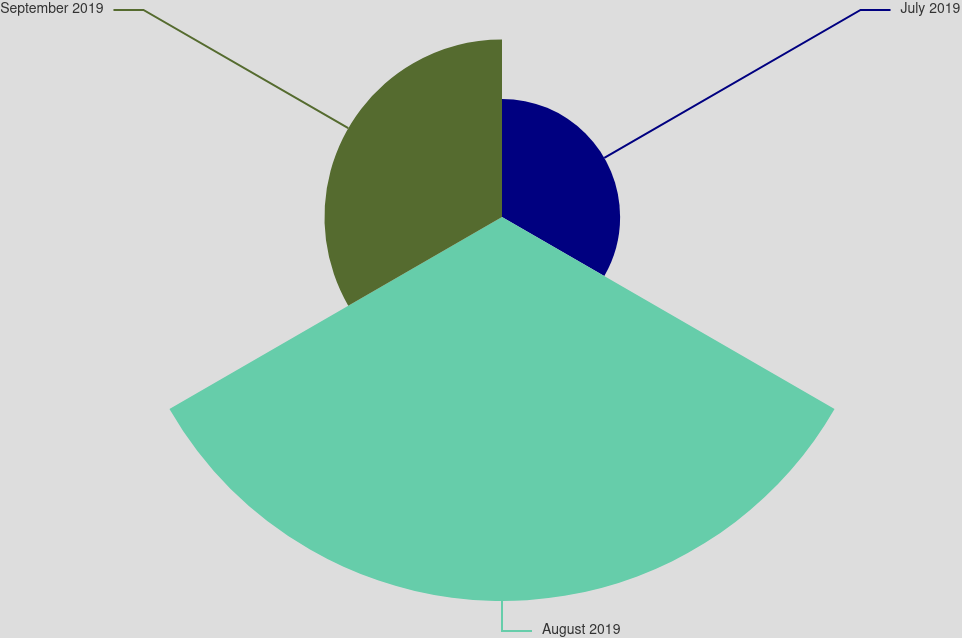Convert chart to OTSL. <chart><loc_0><loc_0><loc_500><loc_500><pie_chart><fcel>July 2019<fcel>August 2019<fcel>September 2019<nl><fcel>17.38%<fcel>56.5%<fcel>26.12%<nl></chart> 